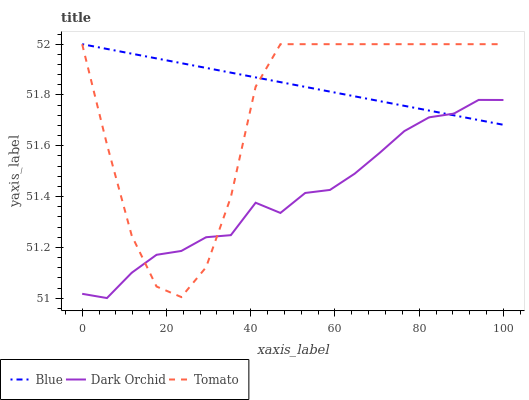Does Dark Orchid have the minimum area under the curve?
Answer yes or no. Yes. Does Blue have the maximum area under the curve?
Answer yes or no. Yes. Does Tomato have the minimum area under the curve?
Answer yes or no. No. Does Tomato have the maximum area under the curve?
Answer yes or no. No. Is Blue the smoothest?
Answer yes or no. Yes. Is Tomato the roughest?
Answer yes or no. Yes. Is Dark Orchid the smoothest?
Answer yes or no. No. Is Dark Orchid the roughest?
Answer yes or no. No. Does Dark Orchid have the lowest value?
Answer yes or no. Yes. Does Tomato have the lowest value?
Answer yes or no. No. Does Tomato have the highest value?
Answer yes or no. Yes. Does Dark Orchid have the highest value?
Answer yes or no. No. Does Dark Orchid intersect Blue?
Answer yes or no. Yes. Is Dark Orchid less than Blue?
Answer yes or no. No. Is Dark Orchid greater than Blue?
Answer yes or no. No. 